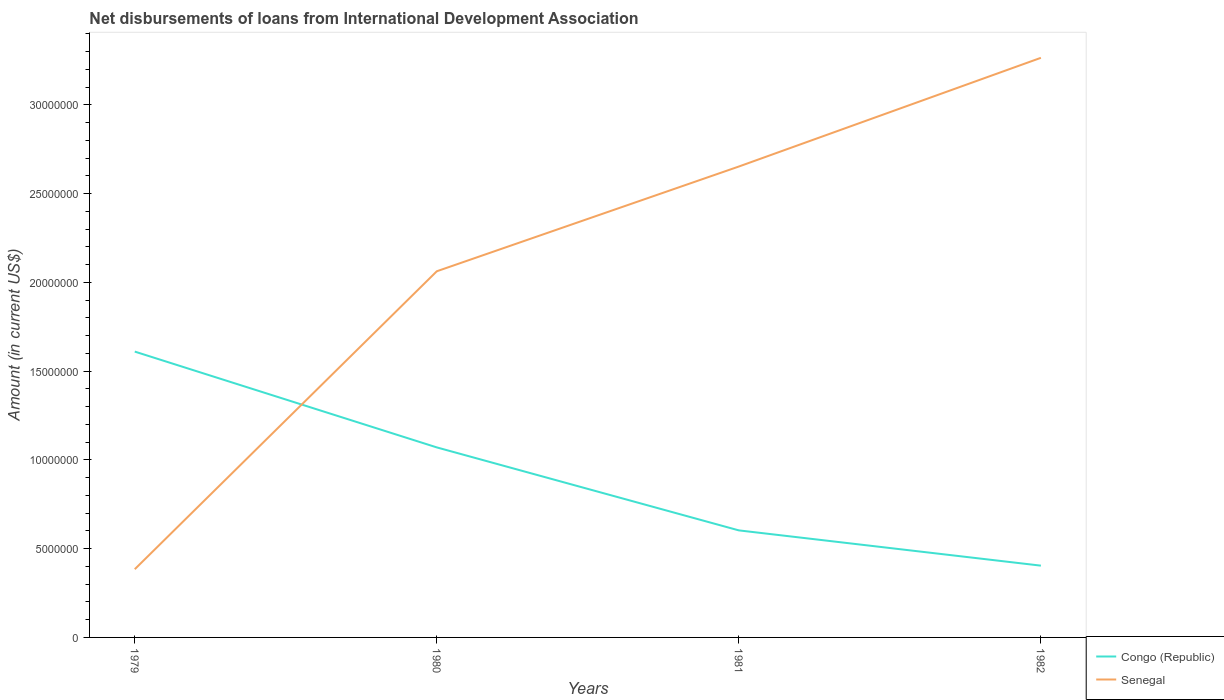How many different coloured lines are there?
Offer a very short reply. 2. Does the line corresponding to Congo (Republic) intersect with the line corresponding to Senegal?
Your answer should be compact. Yes. Across all years, what is the maximum amount of loans disbursed in Senegal?
Make the answer very short. 3.84e+06. In which year was the amount of loans disbursed in Congo (Republic) maximum?
Your response must be concise. 1982. What is the total amount of loans disbursed in Congo (Republic) in the graph?
Ensure brevity in your answer.  4.67e+06. What is the difference between the highest and the second highest amount of loans disbursed in Senegal?
Make the answer very short. 2.88e+07. What is the difference between the highest and the lowest amount of loans disbursed in Senegal?
Offer a terse response. 2. Is the amount of loans disbursed in Senegal strictly greater than the amount of loans disbursed in Congo (Republic) over the years?
Make the answer very short. No. How are the legend labels stacked?
Your response must be concise. Vertical. What is the title of the graph?
Offer a terse response. Net disbursements of loans from International Development Association. What is the label or title of the X-axis?
Give a very brief answer. Years. What is the label or title of the Y-axis?
Your response must be concise. Amount (in current US$). What is the Amount (in current US$) in Congo (Republic) in 1979?
Make the answer very short. 1.61e+07. What is the Amount (in current US$) of Senegal in 1979?
Provide a succinct answer. 3.84e+06. What is the Amount (in current US$) in Congo (Republic) in 1980?
Give a very brief answer. 1.07e+07. What is the Amount (in current US$) in Senegal in 1980?
Keep it short and to the point. 2.06e+07. What is the Amount (in current US$) in Congo (Republic) in 1981?
Ensure brevity in your answer.  6.03e+06. What is the Amount (in current US$) in Senegal in 1981?
Offer a very short reply. 2.65e+07. What is the Amount (in current US$) in Congo (Republic) in 1982?
Your answer should be compact. 4.04e+06. What is the Amount (in current US$) in Senegal in 1982?
Your response must be concise. 3.26e+07. Across all years, what is the maximum Amount (in current US$) in Congo (Republic)?
Give a very brief answer. 1.61e+07. Across all years, what is the maximum Amount (in current US$) in Senegal?
Offer a terse response. 3.26e+07. Across all years, what is the minimum Amount (in current US$) of Congo (Republic)?
Provide a succinct answer. 4.04e+06. Across all years, what is the minimum Amount (in current US$) of Senegal?
Give a very brief answer. 3.84e+06. What is the total Amount (in current US$) of Congo (Republic) in the graph?
Give a very brief answer. 3.69e+07. What is the total Amount (in current US$) in Senegal in the graph?
Offer a very short reply. 8.36e+07. What is the difference between the Amount (in current US$) in Congo (Republic) in 1979 and that in 1980?
Offer a very short reply. 5.40e+06. What is the difference between the Amount (in current US$) in Senegal in 1979 and that in 1980?
Offer a terse response. -1.68e+07. What is the difference between the Amount (in current US$) in Congo (Republic) in 1979 and that in 1981?
Ensure brevity in your answer.  1.01e+07. What is the difference between the Amount (in current US$) of Senegal in 1979 and that in 1981?
Your response must be concise. -2.27e+07. What is the difference between the Amount (in current US$) in Congo (Republic) in 1979 and that in 1982?
Ensure brevity in your answer.  1.21e+07. What is the difference between the Amount (in current US$) of Senegal in 1979 and that in 1982?
Give a very brief answer. -2.88e+07. What is the difference between the Amount (in current US$) in Congo (Republic) in 1980 and that in 1981?
Offer a terse response. 4.67e+06. What is the difference between the Amount (in current US$) of Senegal in 1980 and that in 1981?
Your answer should be compact. -5.90e+06. What is the difference between the Amount (in current US$) in Congo (Republic) in 1980 and that in 1982?
Make the answer very short. 6.66e+06. What is the difference between the Amount (in current US$) of Senegal in 1980 and that in 1982?
Your answer should be very brief. -1.20e+07. What is the difference between the Amount (in current US$) in Congo (Republic) in 1981 and that in 1982?
Make the answer very short. 1.99e+06. What is the difference between the Amount (in current US$) of Senegal in 1981 and that in 1982?
Keep it short and to the point. -6.12e+06. What is the difference between the Amount (in current US$) in Congo (Republic) in 1979 and the Amount (in current US$) in Senegal in 1980?
Provide a succinct answer. -4.52e+06. What is the difference between the Amount (in current US$) in Congo (Republic) in 1979 and the Amount (in current US$) in Senegal in 1981?
Provide a succinct answer. -1.04e+07. What is the difference between the Amount (in current US$) in Congo (Republic) in 1979 and the Amount (in current US$) in Senegal in 1982?
Keep it short and to the point. -1.65e+07. What is the difference between the Amount (in current US$) in Congo (Republic) in 1980 and the Amount (in current US$) in Senegal in 1981?
Make the answer very short. -1.58e+07. What is the difference between the Amount (in current US$) in Congo (Republic) in 1980 and the Amount (in current US$) in Senegal in 1982?
Give a very brief answer. -2.19e+07. What is the difference between the Amount (in current US$) in Congo (Republic) in 1981 and the Amount (in current US$) in Senegal in 1982?
Provide a short and direct response. -2.66e+07. What is the average Amount (in current US$) of Congo (Republic) per year?
Provide a short and direct response. 9.22e+06. What is the average Amount (in current US$) of Senegal per year?
Your answer should be very brief. 2.09e+07. In the year 1979, what is the difference between the Amount (in current US$) of Congo (Republic) and Amount (in current US$) of Senegal?
Provide a succinct answer. 1.23e+07. In the year 1980, what is the difference between the Amount (in current US$) of Congo (Republic) and Amount (in current US$) of Senegal?
Ensure brevity in your answer.  -9.92e+06. In the year 1981, what is the difference between the Amount (in current US$) in Congo (Republic) and Amount (in current US$) in Senegal?
Provide a succinct answer. -2.05e+07. In the year 1982, what is the difference between the Amount (in current US$) of Congo (Republic) and Amount (in current US$) of Senegal?
Provide a short and direct response. -2.86e+07. What is the ratio of the Amount (in current US$) of Congo (Republic) in 1979 to that in 1980?
Ensure brevity in your answer.  1.5. What is the ratio of the Amount (in current US$) of Senegal in 1979 to that in 1980?
Ensure brevity in your answer.  0.19. What is the ratio of the Amount (in current US$) of Congo (Republic) in 1979 to that in 1981?
Offer a terse response. 2.67. What is the ratio of the Amount (in current US$) of Senegal in 1979 to that in 1981?
Your answer should be very brief. 0.14. What is the ratio of the Amount (in current US$) of Congo (Republic) in 1979 to that in 1982?
Give a very brief answer. 3.98. What is the ratio of the Amount (in current US$) in Senegal in 1979 to that in 1982?
Offer a very short reply. 0.12. What is the ratio of the Amount (in current US$) of Congo (Republic) in 1980 to that in 1981?
Give a very brief answer. 1.78. What is the ratio of the Amount (in current US$) in Senegal in 1980 to that in 1981?
Ensure brevity in your answer.  0.78. What is the ratio of the Amount (in current US$) in Congo (Republic) in 1980 to that in 1982?
Keep it short and to the point. 2.65. What is the ratio of the Amount (in current US$) of Senegal in 1980 to that in 1982?
Offer a terse response. 0.63. What is the ratio of the Amount (in current US$) of Congo (Republic) in 1981 to that in 1982?
Give a very brief answer. 1.49. What is the ratio of the Amount (in current US$) of Senegal in 1981 to that in 1982?
Your answer should be very brief. 0.81. What is the difference between the highest and the second highest Amount (in current US$) in Congo (Republic)?
Ensure brevity in your answer.  5.40e+06. What is the difference between the highest and the second highest Amount (in current US$) of Senegal?
Provide a succinct answer. 6.12e+06. What is the difference between the highest and the lowest Amount (in current US$) in Congo (Republic)?
Offer a terse response. 1.21e+07. What is the difference between the highest and the lowest Amount (in current US$) of Senegal?
Your answer should be compact. 2.88e+07. 